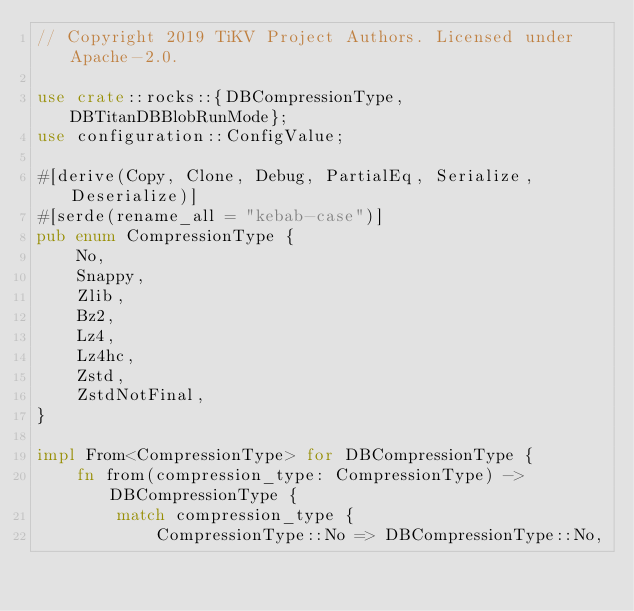<code> <loc_0><loc_0><loc_500><loc_500><_Rust_>// Copyright 2019 TiKV Project Authors. Licensed under Apache-2.0.

use crate::rocks::{DBCompressionType, DBTitanDBBlobRunMode};
use configuration::ConfigValue;

#[derive(Copy, Clone, Debug, PartialEq, Serialize, Deserialize)]
#[serde(rename_all = "kebab-case")]
pub enum CompressionType {
    No,
    Snappy,
    Zlib,
    Bz2,
    Lz4,
    Lz4hc,
    Zstd,
    ZstdNotFinal,
}

impl From<CompressionType> for DBCompressionType {
    fn from(compression_type: CompressionType) -> DBCompressionType {
        match compression_type {
            CompressionType::No => DBCompressionType::No,</code> 